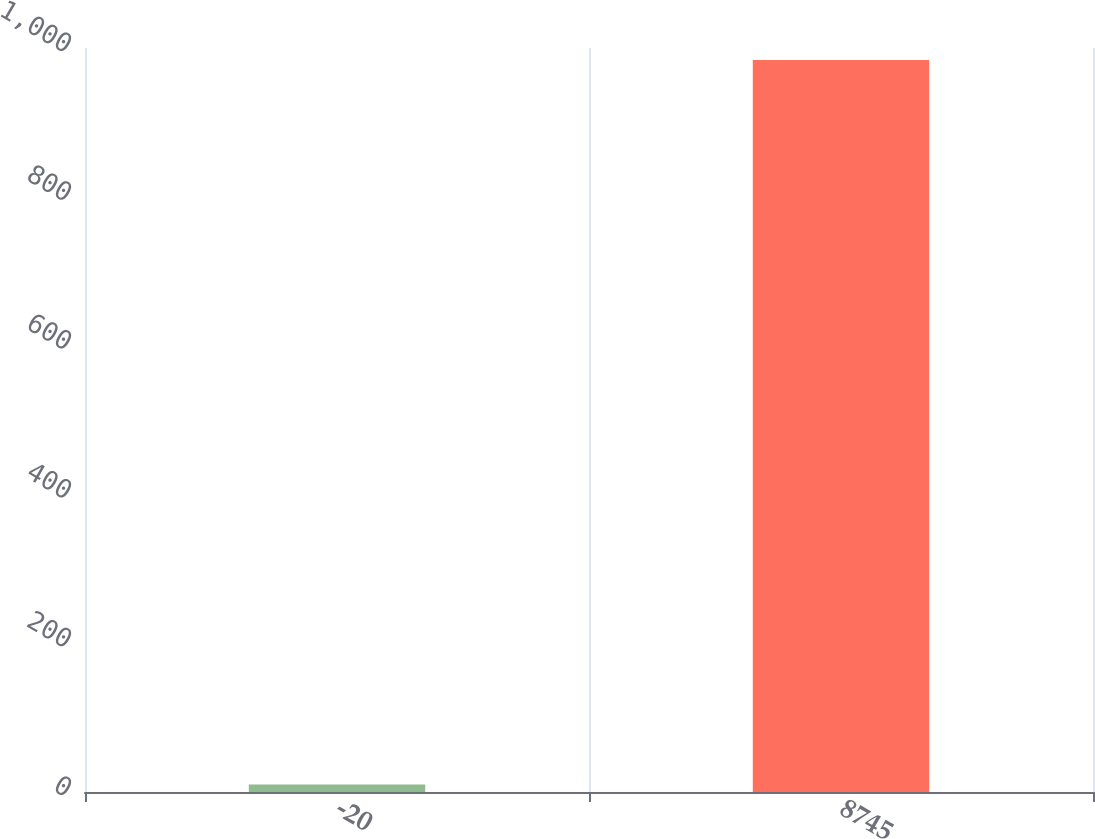<chart> <loc_0><loc_0><loc_500><loc_500><bar_chart><fcel>-20<fcel>8745<nl><fcel>10<fcel>983.8<nl></chart> 